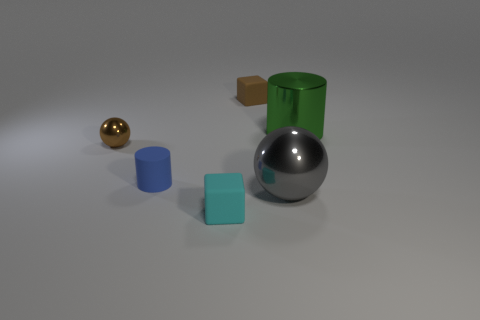Add 1 tiny matte cylinders. How many objects exist? 7 Subtract all cubes. How many objects are left? 4 Add 4 large yellow rubber things. How many large yellow rubber things exist? 4 Subtract 0 blue balls. How many objects are left? 6 Subtract all small brown matte things. Subtract all brown rubber blocks. How many objects are left? 4 Add 2 brown metallic objects. How many brown metallic objects are left? 3 